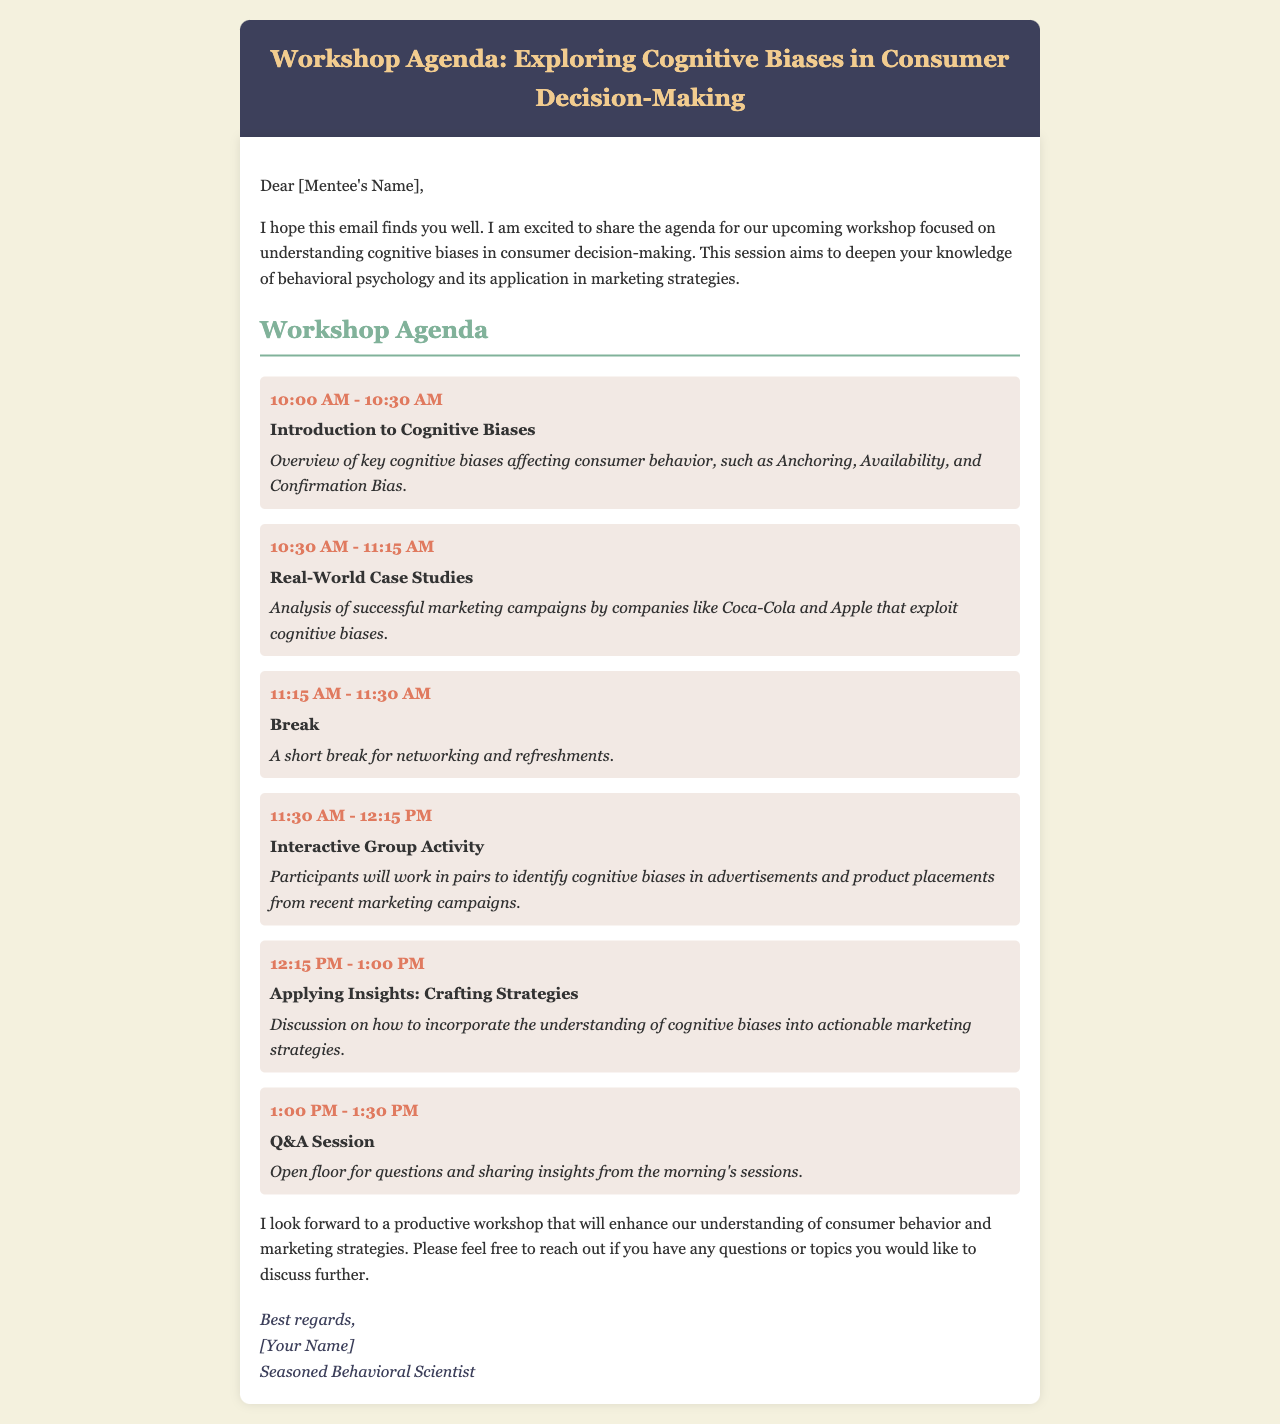What is the workshop's main focus? The main focus of the workshop is on understanding cognitive biases in consumer decision-making, as mentioned in the introductory paragraph.
Answer: Cognitive biases Who will conduct the workshop? The signature at the end indicates that a seasoned behavioral scientist will guide the workshop.
Answer: Seasoned Behavioral Scientist When does the workshop start? The agenda item list indicates that the workshop starts at 10:00 AM.
Answer: 10:00 AM What companies are mentioned in the case studies? The document lists Coca-Cola and Apple as examples in the case studies section.
Answer: Coca-Cola and Apple How long is the Q&A session? The agenda specifies that the Q&A session lasts for 30 minutes, from 1:00 PM to 1:30 PM.
Answer: 30 minutes What activity is planned after the break? The agenda describes an interactive group activity where participants identify cognitive biases in advertisements.
Answer: Interactive Group Activity What is covered during the first agenda item? The first agenda item provides an overview of key cognitive biases affecting consumer behavior.
Answer: Introduction to Cognitive Biases 